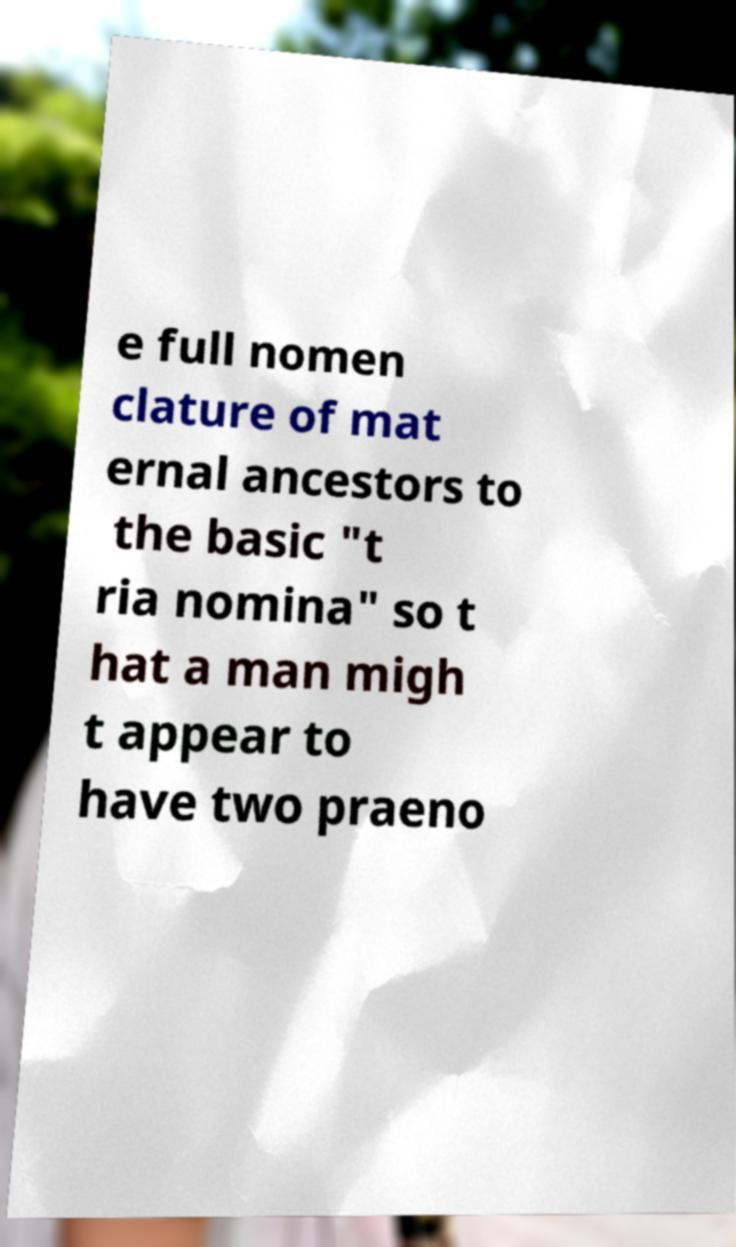For documentation purposes, I need the text within this image transcribed. Could you provide that? e full nomen clature of mat ernal ancestors to the basic "t ria nomina" so t hat a man migh t appear to have two praeno 